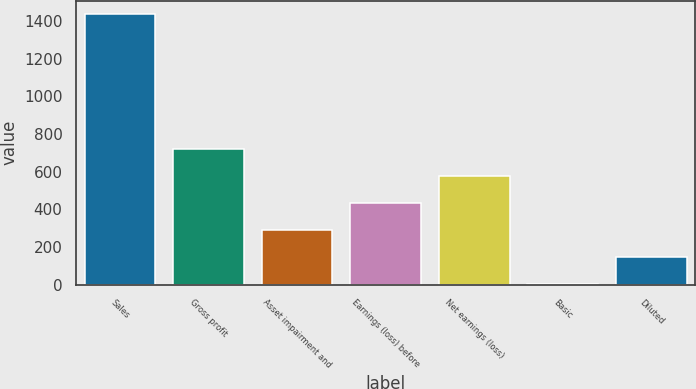Convert chart. <chart><loc_0><loc_0><loc_500><loc_500><bar_chart><fcel>Sales<fcel>Gross profit<fcel>Asset impairment and<fcel>Earnings (loss) before<fcel>Net earnings (loss)<fcel>Basic<fcel>Diluted<nl><fcel>1434<fcel>717.08<fcel>286.91<fcel>430.3<fcel>573.69<fcel>0.13<fcel>143.52<nl></chart> 